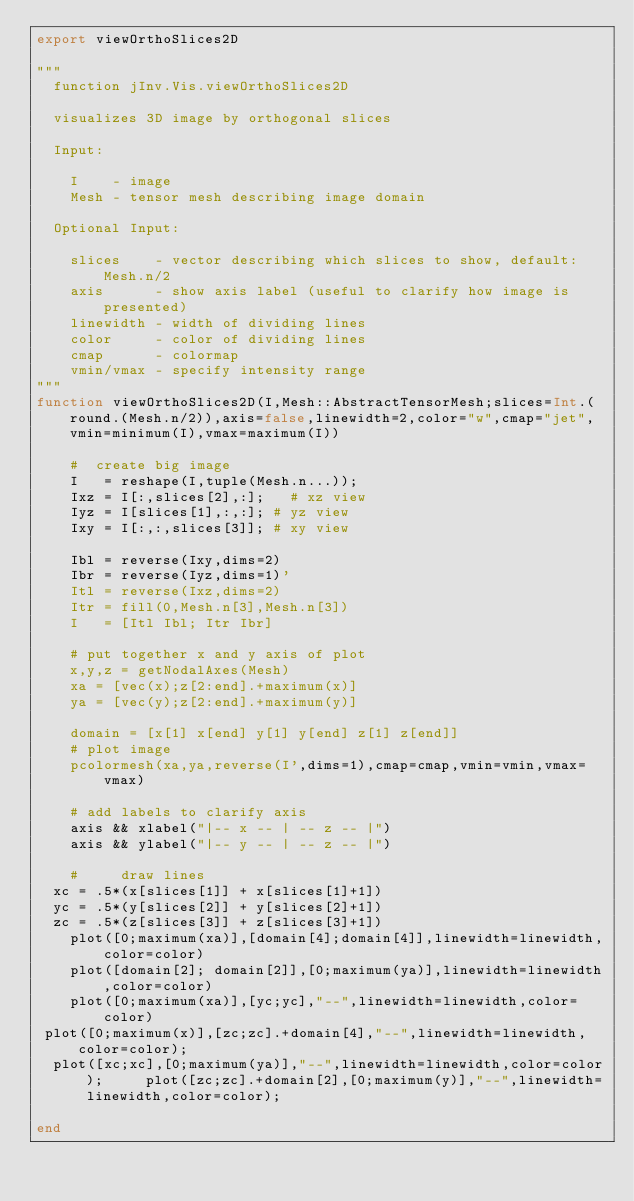<code> <loc_0><loc_0><loc_500><loc_500><_Julia_>export viewOrthoSlices2D

"""
	function jInv.Vis.viewOrthoSlices2D

	visualizes 3D image by orthogonal slices

	Input:

		I    - image
		Mesh - tensor mesh describing image domain

	Optional Input:

		slices    - vector describing which slices to show, default: Mesh.n/2
		axis      - show axis label (useful to clarify how image is presented)
		linewidth - width of dividing lines
		color     - color of dividing lines
		cmap      - colormap
		vmin/vmax - specify intensity range
"""
function viewOrthoSlices2D(I,Mesh::AbstractTensorMesh;slices=Int.(round.(Mesh.n/2)),axis=false,linewidth=2,color="w",cmap="jet",vmin=minimum(I),vmax=maximum(I))

    #  create big image
    I   = reshape(I,tuple(Mesh.n...));
    Ixz = I[:,slices[2],:];   # xz view
    Iyz = I[slices[1],:,:]; # yz view
    Ixy = I[:,:,slices[3]]; # xy view

    Ibl = reverse(Ixy,dims=2)
    Ibr = reverse(Iyz,dims=1)'
    Itl = reverse(Ixz,dims=2)
    Itr = fill(0,Mesh.n[3],Mesh.n[3])
    I   = [Itl Ibl; Itr Ibr]

    # put together x and y axis of plot
    x,y,z = getNodalAxes(Mesh)
    xa = [vec(x);z[2:end].+maximum(x)]
    ya = [vec(y);z[2:end].+maximum(y)]

    domain = [x[1] x[end] y[1] y[end] z[1] z[end]]
    # plot image
    pcolormesh(xa,ya,reverse(I',dims=1),cmap=cmap,vmin=vmin,vmax=vmax)

    # add labels to clarify axis
    axis && xlabel("|-- x -- | -- z -- |")
    axis && ylabel("|-- y -- | -- z -- |")

    #     draw lines
	xc = .5*(x[slices[1]] + x[slices[1]+1])
	yc = .5*(y[slices[2]] + y[slices[2]+1])
	zc = .5*(z[slices[3]] + z[slices[3]+1])
    plot([0;maximum(xa)],[domain[4];domain[4]],linewidth=linewidth,color=color)
    plot([domain[2]; domain[2]],[0;maximum(ya)],linewidth=linewidth,color=color)
    plot([0;maximum(xa)],[yc;yc],"--",linewidth=linewidth,color=color)
 plot([0;maximum(x)],[zc;zc].+domain[4],"--",linewidth=linewidth,color=color);
  plot([xc;xc],[0;maximum(ya)],"--",linewidth=linewidth,color=color);	    plot([zc;zc].+domain[2],[0;maximum(y)],"--",linewidth=linewidth,color=color);

end
</code> 